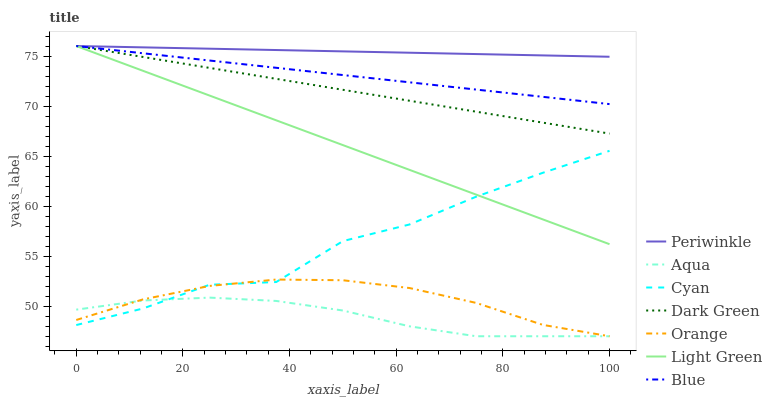Does Aqua have the minimum area under the curve?
Answer yes or no. Yes. Does Periwinkle have the maximum area under the curve?
Answer yes or no. Yes. Does Periwinkle have the minimum area under the curve?
Answer yes or no. No. Does Aqua have the maximum area under the curve?
Answer yes or no. No. Is Light Green the smoothest?
Answer yes or no. Yes. Is Cyan the roughest?
Answer yes or no. Yes. Is Aqua the smoothest?
Answer yes or no. No. Is Aqua the roughest?
Answer yes or no. No. Does Aqua have the lowest value?
Answer yes or no. Yes. Does Periwinkle have the lowest value?
Answer yes or no. No. Does Dark Green have the highest value?
Answer yes or no. Yes. Does Aqua have the highest value?
Answer yes or no. No. Is Cyan less than Blue?
Answer yes or no. Yes. Is Dark Green greater than Cyan?
Answer yes or no. Yes. Does Light Green intersect Cyan?
Answer yes or no. Yes. Is Light Green less than Cyan?
Answer yes or no. No. Is Light Green greater than Cyan?
Answer yes or no. No. Does Cyan intersect Blue?
Answer yes or no. No. 